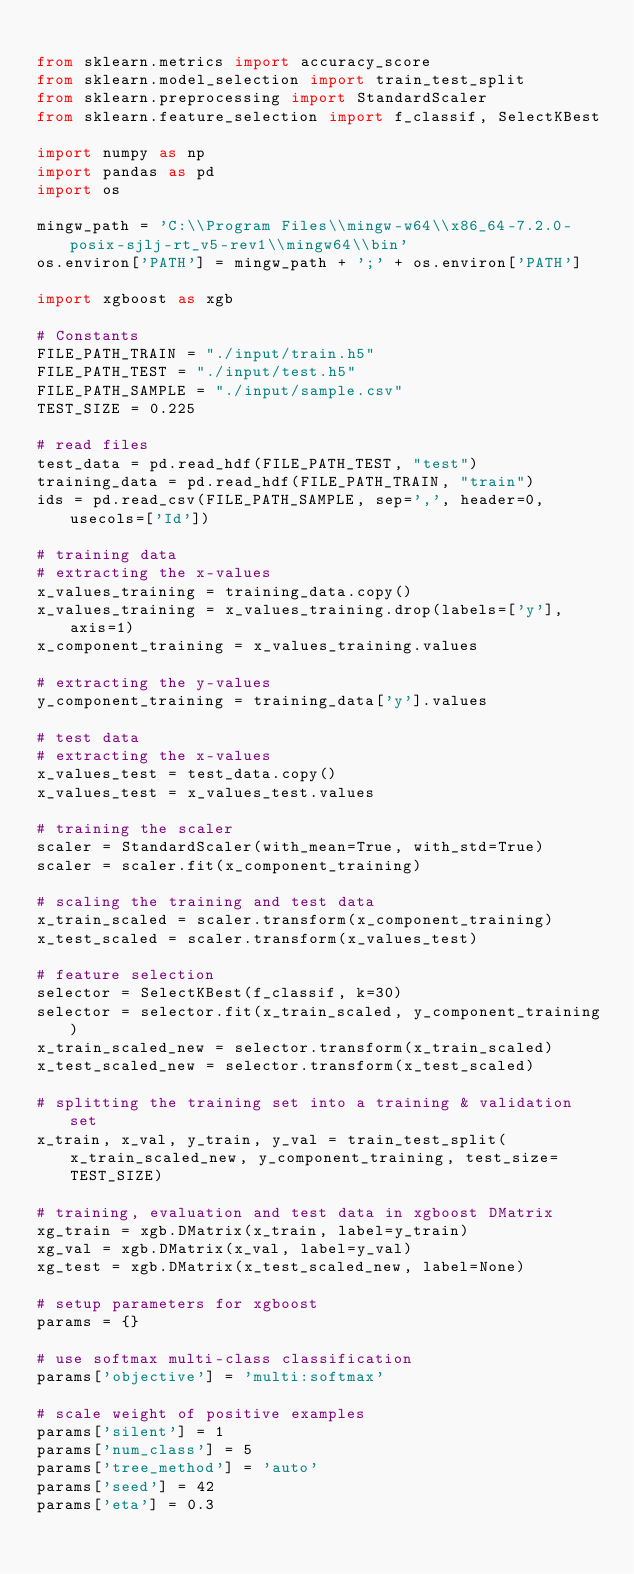<code> <loc_0><loc_0><loc_500><loc_500><_Python_>
from sklearn.metrics import accuracy_score
from sklearn.model_selection import train_test_split
from sklearn.preprocessing import StandardScaler
from sklearn.feature_selection import f_classif, SelectKBest

import numpy as np
import pandas as pd
import os

mingw_path = 'C:\\Program Files\\mingw-w64\\x86_64-7.2.0-posix-sjlj-rt_v5-rev1\\mingw64\\bin'
os.environ['PATH'] = mingw_path + ';' + os.environ['PATH']

import xgboost as xgb

# Constants
FILE_PATH_TRAIN = "./input/train.h5"
FILE_PATH_TEST = "./input/test.h5"
FILE_PATH_SAMPLE = "./input/sample.csv"
TEST_SIZE = 0.225

# read files
test_data = pd.read_hdf(FILE_PATH_TEST, "test")
training_data = pd.read_hdf(FILE_PATH_TRAIN, "train")
ids = pd.read_csv(FILE_PATH_SAMPLE, sep=',', header=0, usecols=['Id'])

# training data
# extracting the x-values 
x_values_training = training_data.copy()
x_values_training = x_values_training.drop(labels=['y'], axis=1)
x_component_training = x_values_training.values

# extracting the y-values
y_component_training = training_data['y'].values

# test data
# extracting the x-values
x_values_test = test_data.copy()
x_values_test = x_values_test.values

# training the scaler
scaler = StandardScaler(with_mean=True, with_std=True)
scaler = scaler.fit(x_component_training)

# scaling the training and test data
x_train_scaled = scaler.transform(x_component_training)
x_test_scaled = scaler.transform(x_values_test)

# feature selection 
selector = SelectKBest(f_classif, k=30)
selector = selector.fit(x_train_scaled, y_component_training)
x_train_scaled_new = selector.transform(x_train_scaled)
x_test_scaled_new = selector.transform(x_test_scaled)

# splitting the training set into a training & validation set
x_train, x_val, y_train, y_val = train_test_split(x_train_scaled_new, y_component_training, test_size=TEST_SIZE)

# training, evaluation and test data in xgboost DMatrix
xg_train = xgb.DMatrix(x_train, label=y_train)
xg_val = xgb.DMatrix(x_val, label=y_val)
xg_test = xgb.DMatrix(x_test_scaled_new, label=None)

# setup parameters for xgboost
params = {}

# use softmax multi-class classification
params['objective'] = 'multi:softmax'

# scale weight of positive examples
params['silent'] = 1
params['num_class'] = 5
params['tree_method'] = 'auto'
params['seed'] = 42
params['eta'] = 0.3</code> 